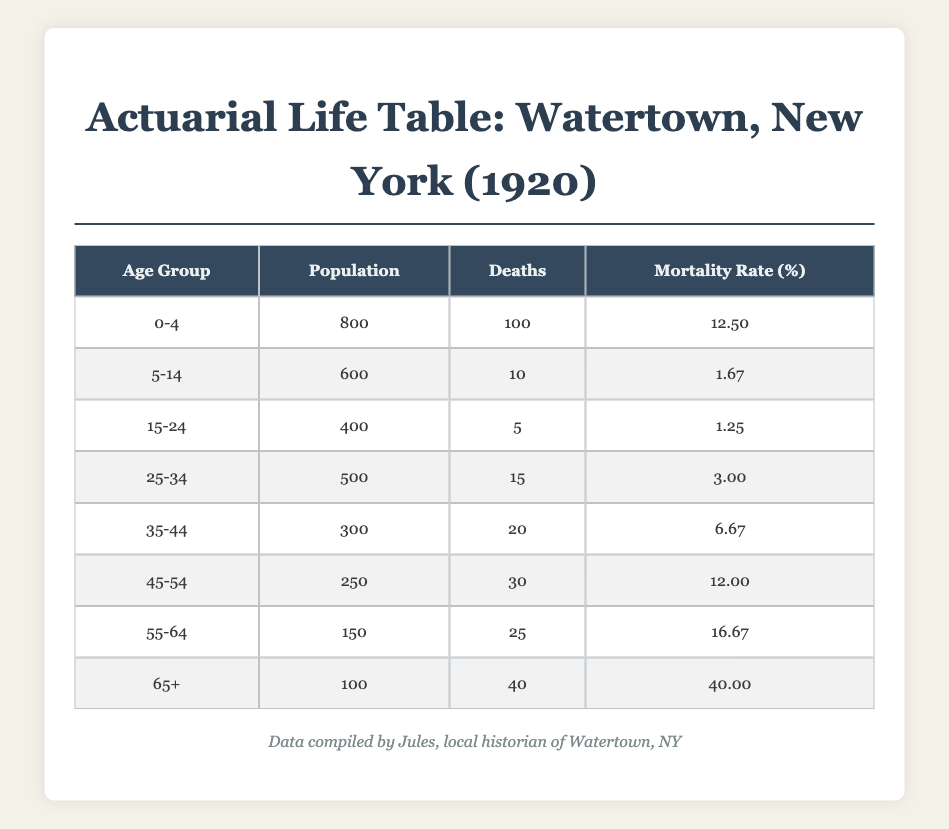What is the mortality rate for infants aged 0-4? According to the table, the mortality rate for the age group 0-4 is given directly as 12.5%.
Answer: 12.5% How many individuals aged 25-34 died in 1920? The table indicates that there were 15 deaths in the age group 25-34.
Answer: 15 What is the total population of individuals aged 45-54 and 55-64 combined? By adding the populations of both groups, we get 250 (45-54) + 150 (55-64) = 400.
Answer: 400 Is the mortality rate for those aged 65 and older the highest among all age groups? Yes, comparing the mortality rates, the rate for the age group 65 and older is 40.0%, which is indeed the highest.
Answer: Yes What is the average mortality rate across all age groups in the table? To find the average, we sum the mortality rates: 12.5 + 1.67 + 1.25 + 3.0 + 6.67 + 12.0 + 16.67 + 40.0 = 93.86. Then divide by the 8 age groups: 93.86/8 = 11.735.
Answer: 11.735 What percentage of the population aged 55-64 died compared to the total population of all age groups? The total population is 800 + 600 + 400 + 500 + 300 + 250 + 150 + 100 = 3100. The 25 deaths in the 55-64 age group represent 25/3100 = 0.00806, or about 0.8%.
Answer: 0.8% Which age group had the lowest mortality rate? The age group 15-24 had the lowest mortality rate of 1.25%.
Answer: 1.25% If the population of 0-4 years old had remained the same, how many more deaths would be expected if the mortality rate were to increase to 15%? With a population of 800 in the 0-4 age group, an increase to a 15% mortality rate would result in 800 * 0.15 = 120 deaths. The difference from the original 100 deaths would be 120 - 100 = 20 additional deaths.
Answer: 20 What is the total number of deaths recorded for all age groups in the table? Summing the deaths from all age groups gives us: 100 + 10 + 5 + 15 + 20 + 30 + 25 + 40 = 250 total deaths.
Answer: 250 